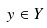<formula> <loc_0><loc_0><loc_500><loc_500>y \in Y</formula> 